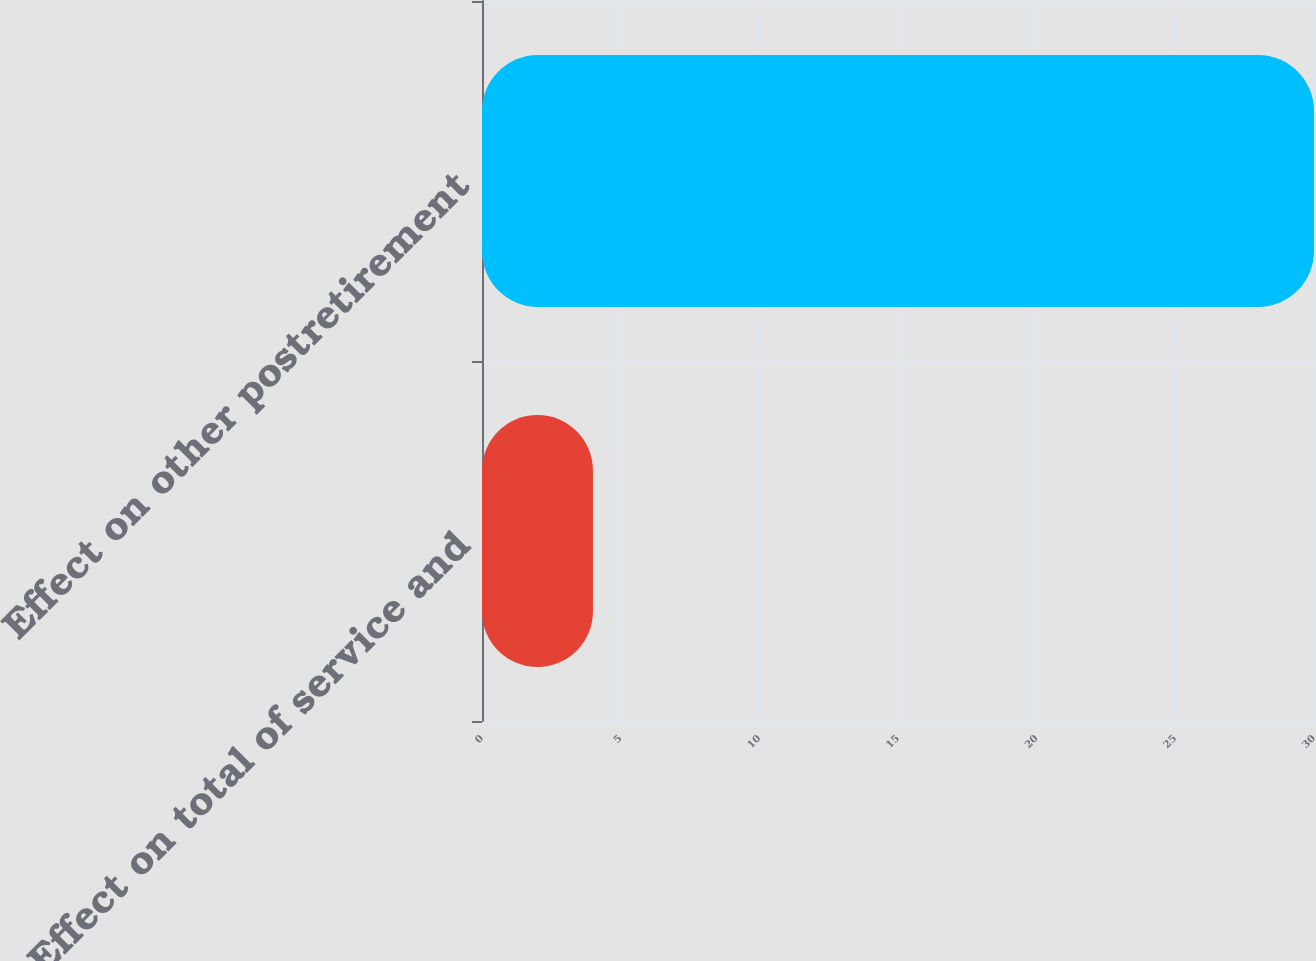Convert chart to OTSL. <chart><loc_0><loc_0><loc_500><loc_500><bar_chart><fcel>Effect on total of service and<fcel>Effect on other postretirement<nl><fcel>4<fcel>30<nl></chart> 